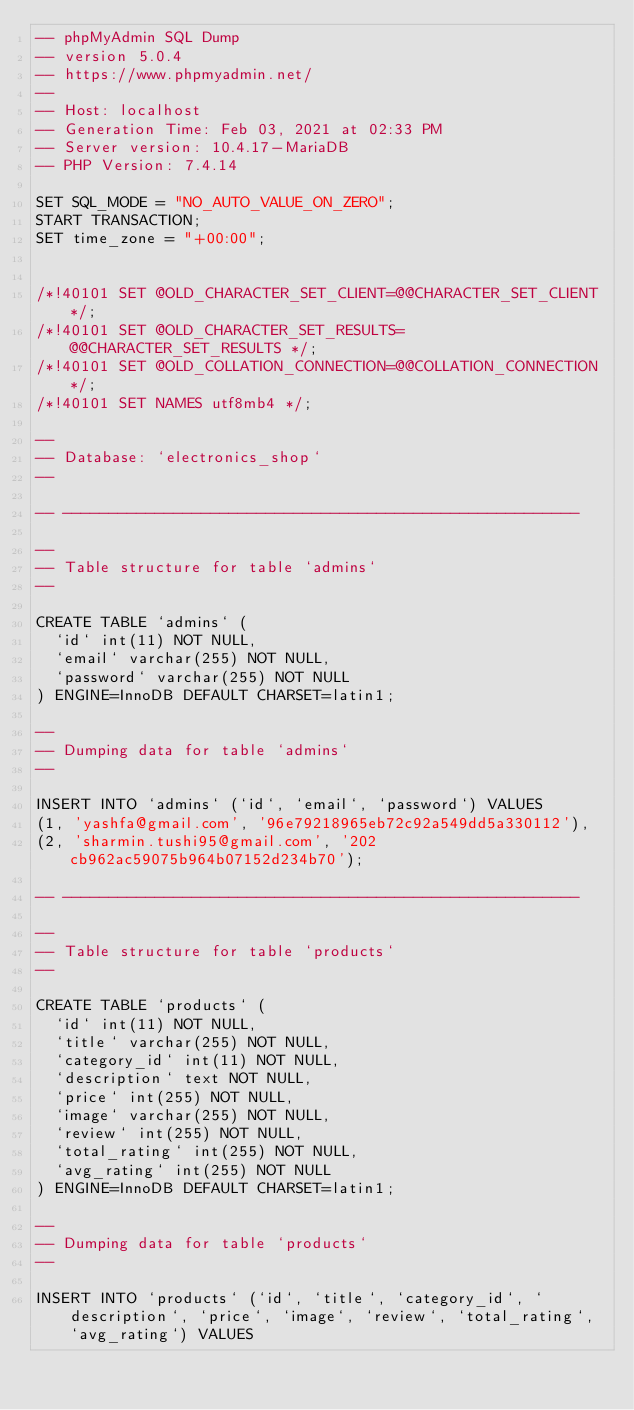Convert code to text. <code><loc_0><loc_0><loc_500><loc_500><_SQL_>-- phpMyAdmin SQL Dump
-- version 5.0.4
-- https://www.phpmyadmin.net/
--
-- Host: localhost
-- Generation Time: Feb 03, 2021 at 02:33 PM
-- Server version: 10.4.17-MariaDB
-- PHP Version: 7.4.14

SET SQL_MODE = "NO_AUTO_VALUE_ON_ZERO";
START TRANSACTION;
SET time_zone = "+00:00";


/*!40101 SET @OLD_CHARACTER_SET_CLIENT=@@CHARACTER_SET_CLIENT */;
/*!40101 SET @OLD_CHARACTER_SET_RESULTS=@@CHARACTER_SET_RESULTS */;
/*!40101 SET @OLD_COLLATION_CONNECTION=@@COLLATION_CONNECTION */;
/*!40101 SET NAMES utf8mb4 */;

--
-- Database: `electronics_shop`
--

-- --------------------------------------------------------

--
-- Table structure for table `admins`
--

CREATE TABLE `admins` (
  `id` int(11) NOT NULL,
  `email` varchar(255) NOT NULL,
  `password` varchar(255) NOT NULL
) ENGINE=InnoDB DEFAULT CHARSET=latin1;

--
-- Dumping data for table `admins`
--

INSERT INTO `admins` (`id`, `email`, `password`) VALUES
(1, 'yashfa@gmail.com', '96e79218965eb72c92a549dd5a330112'),
(2, 'sharmin.tushi95@gmail.com', '202cb962ac59075b964b07152d234b70');

-- --------------------------------------------------------

--
-- Table structure for table `products`
--

CREATE TABLE `products` (
  `id` int(11) NOT NULL,
  `title` varchar(255) NOT NULL,
  `category_id` int(11) NOT NULL,
  `description` text NOT NULL,
  `price` int(255) NOT NULL,
  `image` varchar(255) NOT NULL,
  `review` int(255) NOT NULL,
  `total_rating` int(255) NOT NULL,
  `avg_rating` int(255) NOT NULL
) ENGINE=InnoDB DEFAULT CHARSET=latin1;

--
-- Dumping data for table `products`
--

INSERT INTO `products` (`id`, `title`, `category_id`, `description`, `price`, `image`, `review`, `total_rating`, `avg_rating`) VALUES</code> 